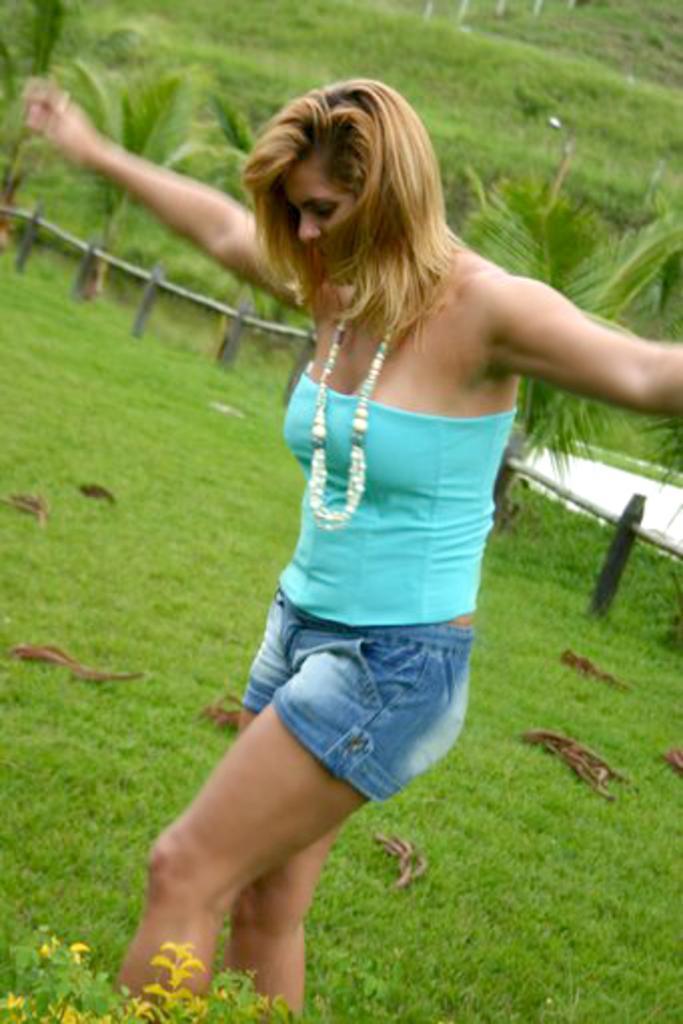Describe this image in one or two sentences. In this image we can see a woman standing and stretching her hands. And we can see the grass. And we can see the wooden fencing. And we can see the trees. And we can see some objects on the grass. 